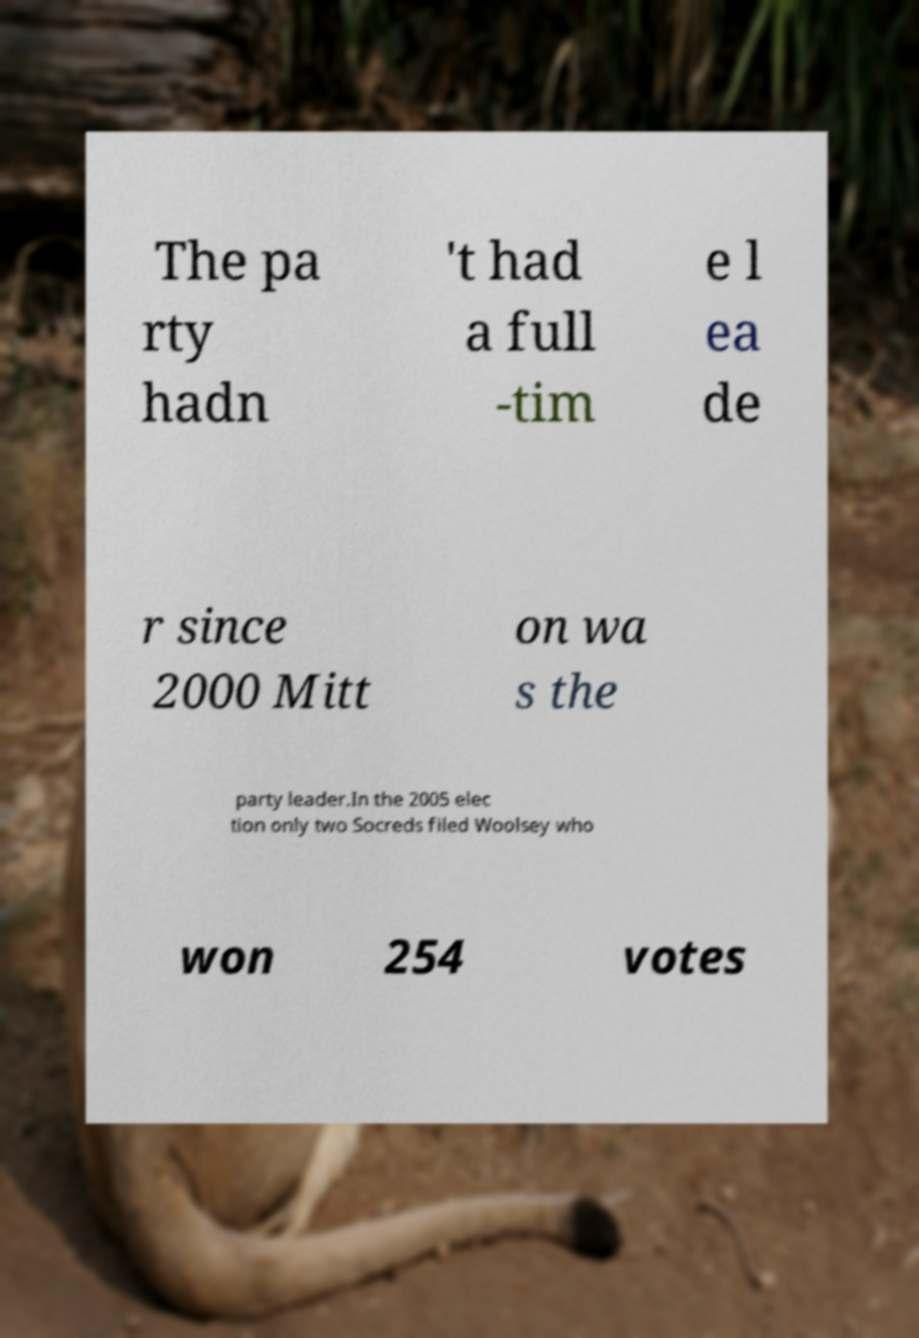I need the written content from this picture converted into text. Can you do that? The pa rty hadn 't had a full -tim e l ea de r since 2000 Mitt on wa s the party leader.In the 2005 elec tion only two Socreds filed Woolsey who won 254 votes 